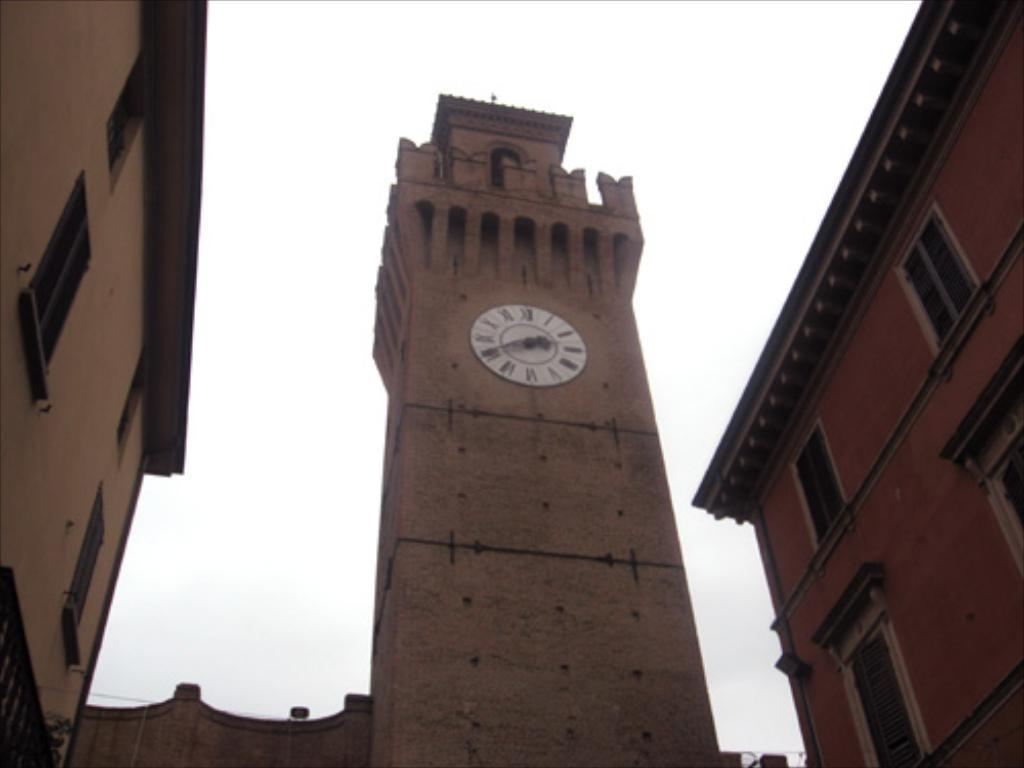What type of structures can be seen in the image? There are buildings in the image. What architectural features are visible on the buildings? There are windows visible on the buildings. What time-telling device is present in the image? There is a wall clock in the image. What can be seen in the background of the image? The sky is visible in the image. Where is the jail located in the image? There is no jail present in the image. What type of work is being done by the people in the image? There are no people visible in the image, so it is impossible to determine what type of work they might be doing. 